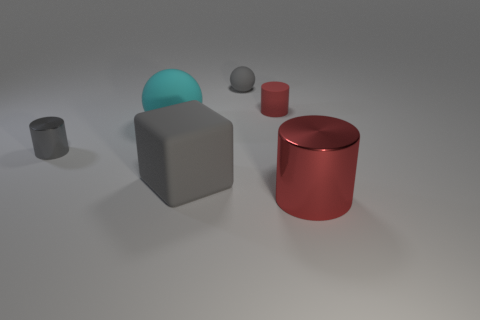Subtract all big metal cylinders. How many cylinders are left? 2 Subtract all blue cubes. How many red cylinders are left? 2 Add 3 big gray matte blocks. How many objects exist? 9 Subtract all gray cylinders. How many cylinders are left? 2 Subtract all spheres. How many objects are left? 4 Subtract 1 cylinders. How many cylinders are left? 2 Subtract 1 gray cubes. How many objects are left? 5 Subtract all blue cylinders. Subtract all gray balls. How many cylinders are left? 3 Subtract all small spheres. Subtract all cyan balls. How many objects are left? 4 Add 6 rubber cylinders. How many rubber cylinders are left? 7 